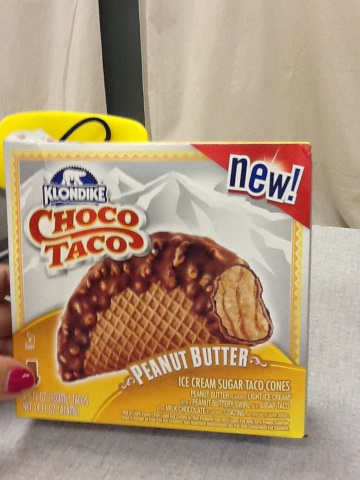what is this? from Vizwiz This is a 'Choco Taco Peanut Butter,' a type of ice cream product by Klondike. It appears to be a new flavor variation and is described as sugar taco cones filled with peanut butter flavor ice cream. 